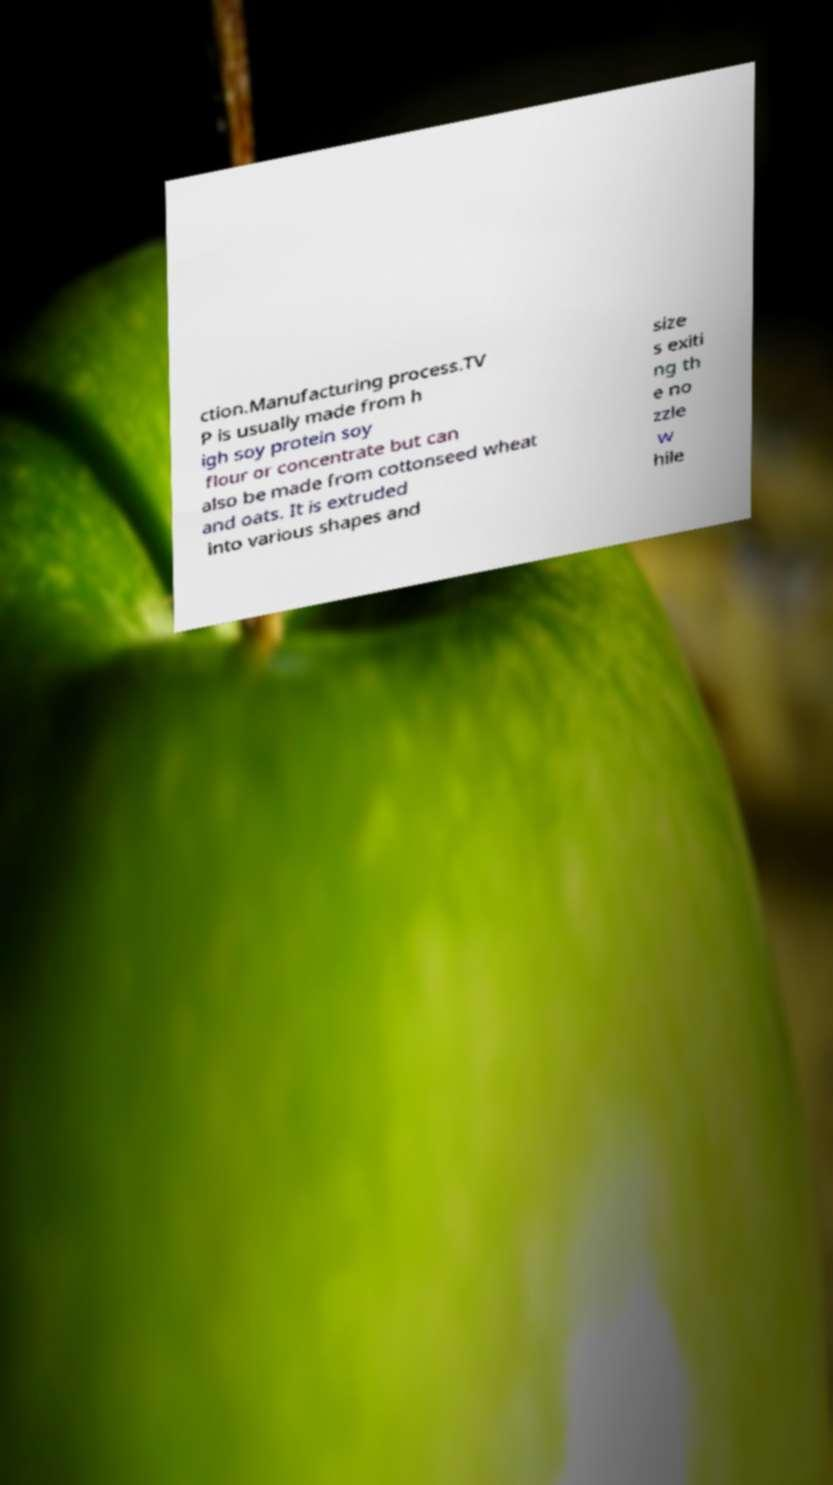For documentation purposes, I need the text within this image transcribed. Could you provide that? ction.Manufacturing process.TV P is usually made from h igh soy protein soy flour or concentrate but can also be made from cottonseed wheat and oats. It is extruded into various shapes and size s exiti ng th e no zzle w hile 